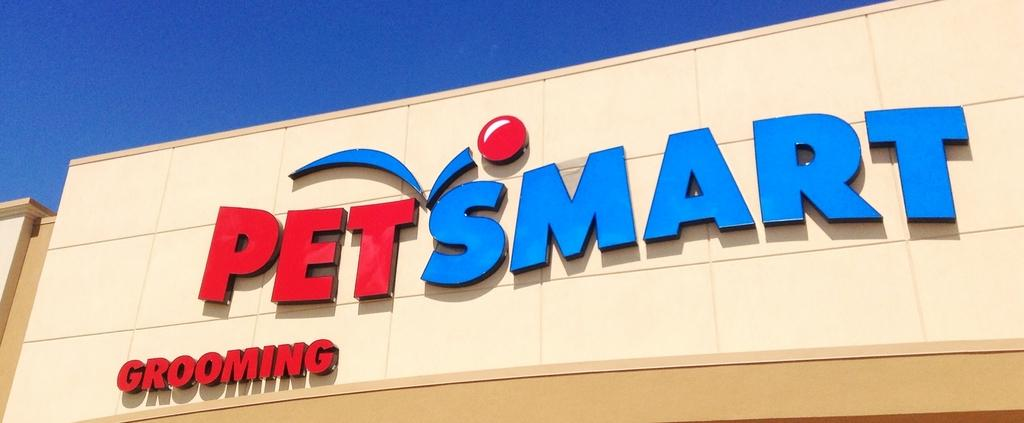What is located in the center of the image? There is a poster in the center of the image. What is written on the poster? The poster has the text "pets mart" on it. What type of string is being used to create the fire in the image? There is no string or fire present in the image; it only features a poster with the text "pets mart" on it. How does the pollution affect the environment in the image? There is no reference to pollution in the image; it only features a poster with the text "pets mart" on it. 